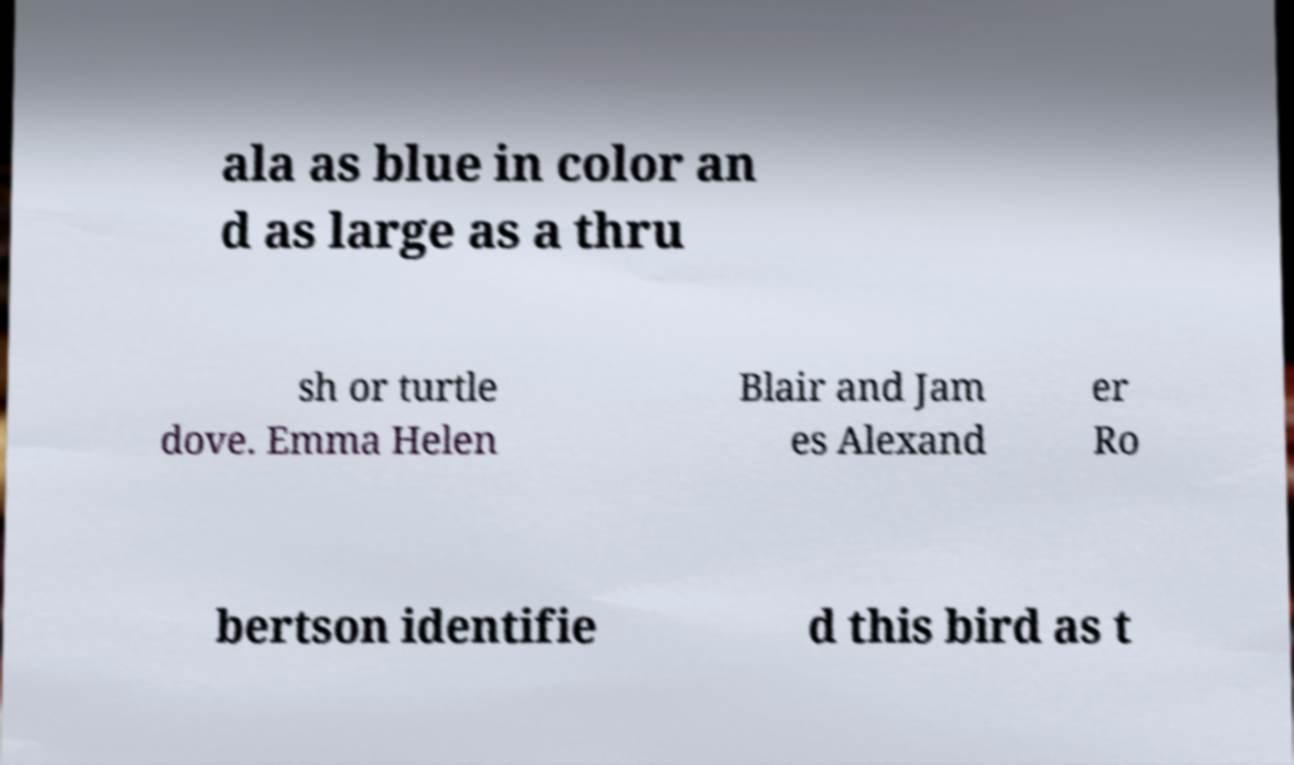Can you read and provide the text displayed in the image?This photo seems to have some interesting text. Can you extract and type it out for me? ala as blue in color an d as large as a thru sh or turtle dove. Emma Helen Blair and Jam es Alexand er Ro bertson identifie d this bird as t 